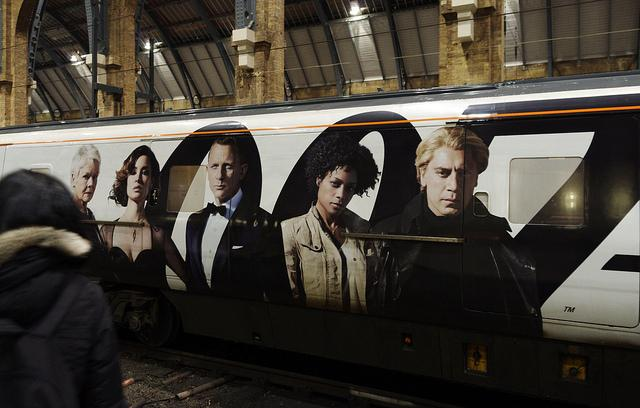Which franchise is advertised here? james bond 